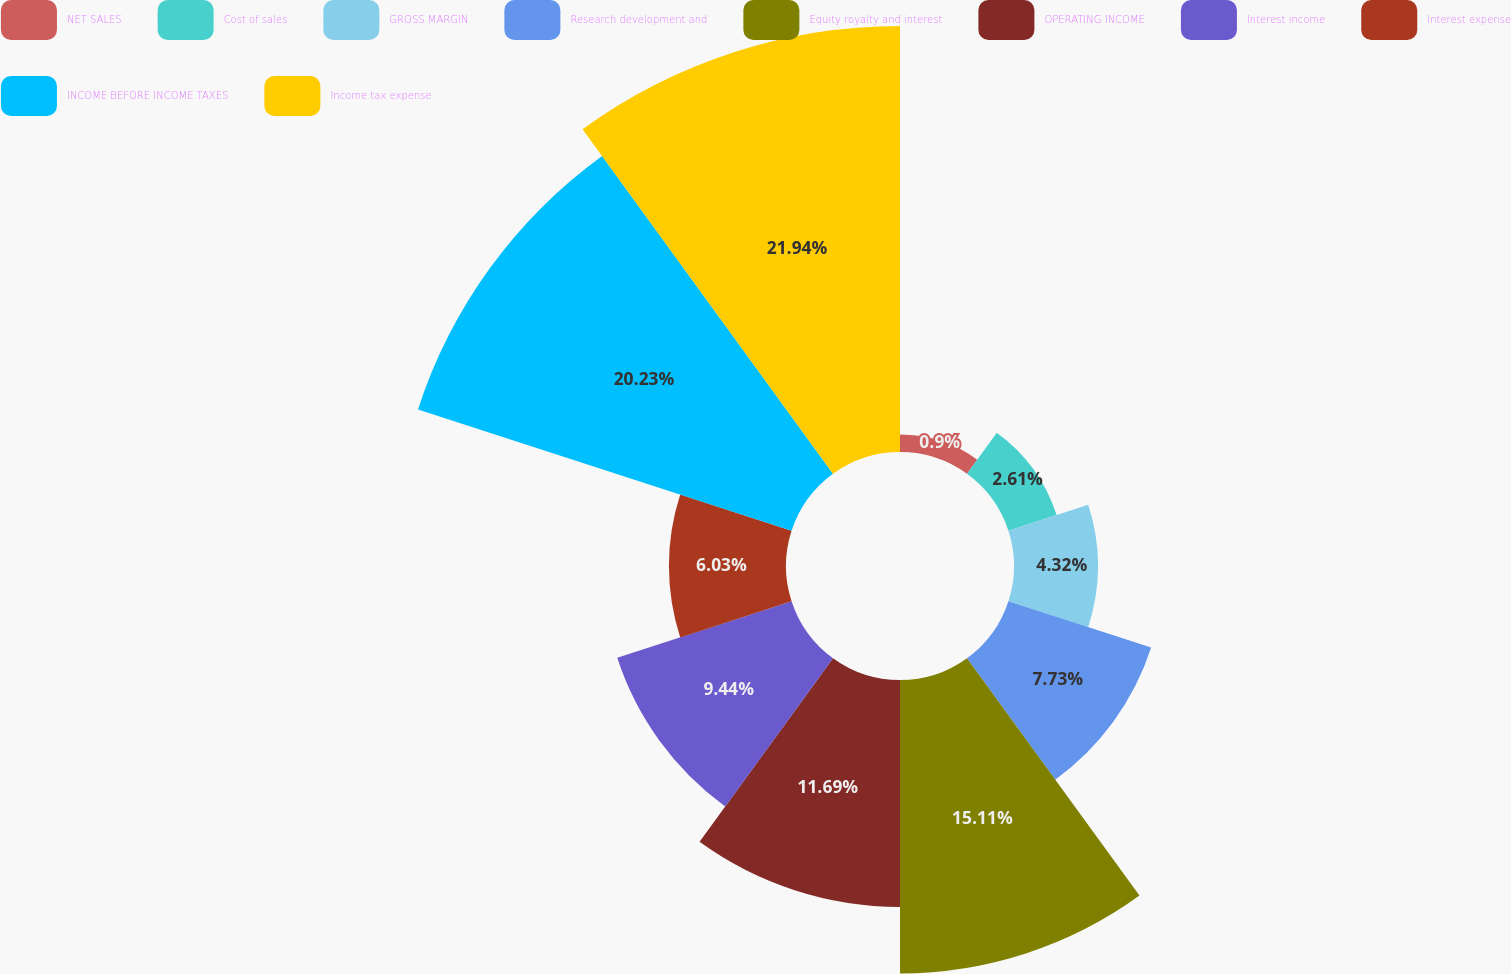Convert chart. <chart><loc_0><loc_0><loc_500><loc_500><pie_chart><fcel>NET SALES<fcel>Cost of sales<fcel>GROSS MARGIN<fcel>Research development and<fcel>Equity royalty and interest<fcel>OPERATING INCOME<fcel>Interest income<fcel>Interest expense<fcel>INCOME BEFORE INCOME TAXES<fcel>Income tax expense<nl><fcel>0.9%<fcel>2.61%<fcel>4.32%<fcel>7.73%<fcel>15.11%<fcel>11.69%<fcel>9.44%<fcel>6.03%<fcel>20.23%<fcel>21.94%<nl></chart> 